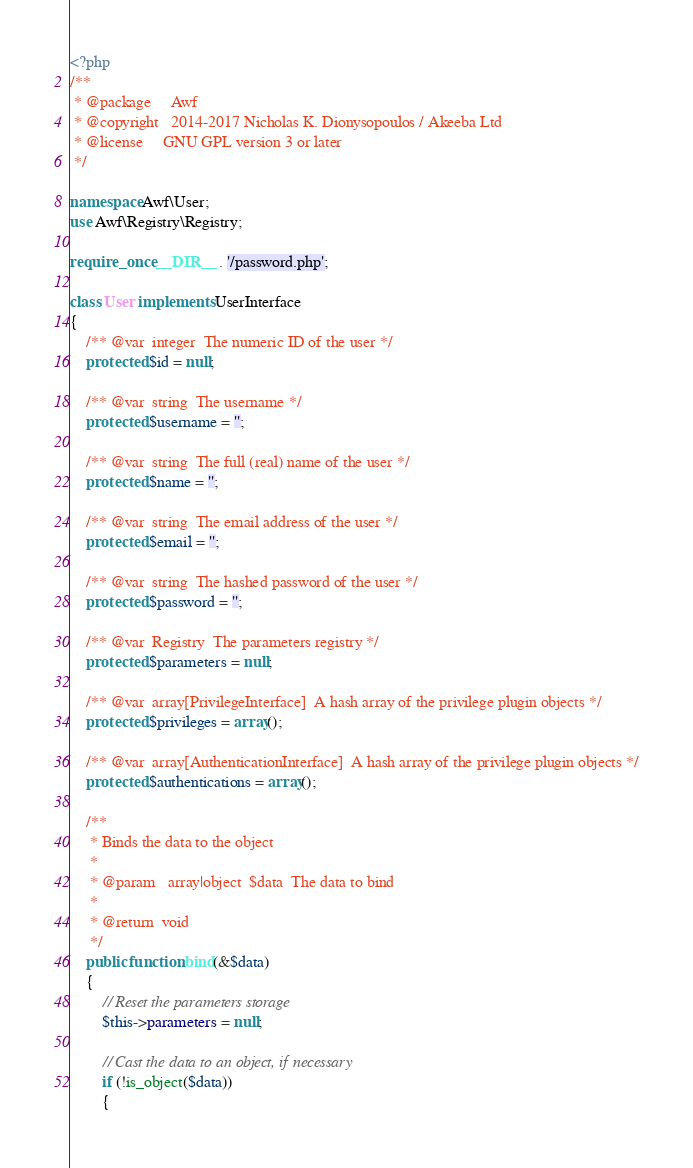<code> <loc_0><loc_0><loc_500><loc_500><_PHP_><?php
/**
 * @package     Awf
 * @copyright   2014-2017 Nicholas K. Dionysopoulos / Akeeba Ltd
 * @license     GNU GPL version 3 or later
 */

namespace Awf\User;
use Awf\Registry\Registry;

require_once __DIR__ . '/password.php';

class User implements UserInterface
{
	/** @var  integer  The numeric ID of the user */
	protected $id = null;

	/** @var  string  The username */
	protected $username = '';

	/** @var  string  The full (real) name of the user */
	protected $name = '';

	/** @var  string  The email address of the user */
	protected $email = '';

	/** @var  string  The hashed password of the user */
	protected $password = '';

	/** @var  Registry  The parameters registry */
	protected $parameters = null;

	/** @var  array[PrivilegeInterface]  A hash array of the privilege plugin objects */
	protected $privileges = array();

	/** @var  array[AuthenticationInterface]  A hash array of the privilege plugin objects */
	protected $authentications = array();

	/**
	 * Binds the data to the object
	 *
	 * @param   array|object  $data  The data to bind
	 *
	 * @return  void
	 */
	public function bind(&$data)
	{
		// Reset the parameters storage
		$this->parameters = null;

		// Cast the data to an object, if necessary
		if (!is_object($data))
		{</code> 